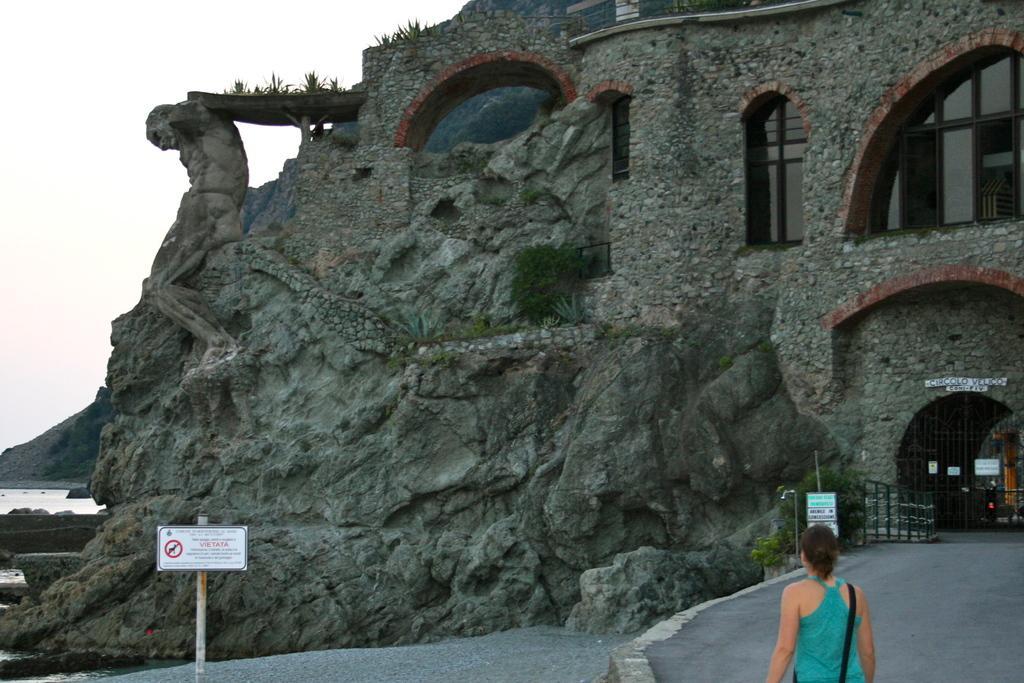How would you summarize this image in a sentence or two? Here in this picture we can see a building present and on the left side we can see rock stone structure present over there and we can also see its windows and gate present over there and in the front we can see a woman standing over there and we can see some boards also present over there and on the left side we can see water over there and we can also see plants present over there. 